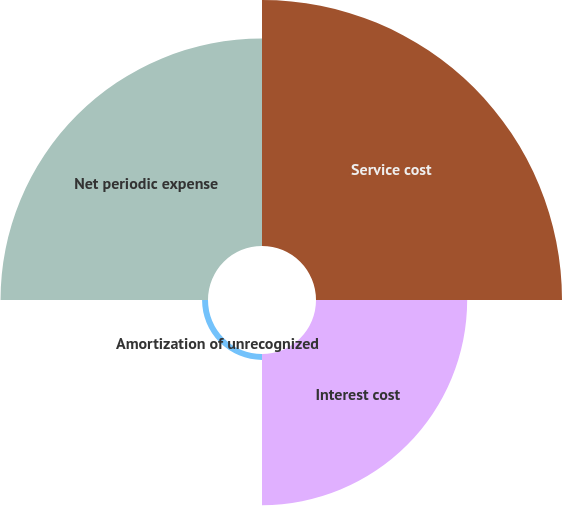Convert chart. <chart><loc_0><loc_0><loc_500><loc_500><pie_chart><fcel>Service cost<fcel>Interest cost<fcel>Amortization of unrecognized<fcel>Net periodic expense<nl><fcel>40.29%<fcel>24.76%<fcel>0.97%<fcel>33.98%<nl></chart> 